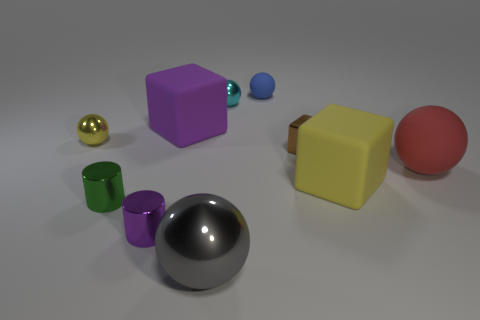Subtract all gray balls. How many balls are left? 4 Subtract all purple spheres. Subtract all blue cylinders. How many spheres are left? 5 Subtract all cylinders. How many objects are left? 8 Subtract all tiny metallic cylinders. Subtract all large red metal balls. How many objects are left? 8 Add 8 tiny rubber balls. How many tiny rubber balls are left? 9 Add 9 brown metal cubes. How many brown metal cubes exist? 10 Subtract 0 blue cylinders. How many objects are left? 10 